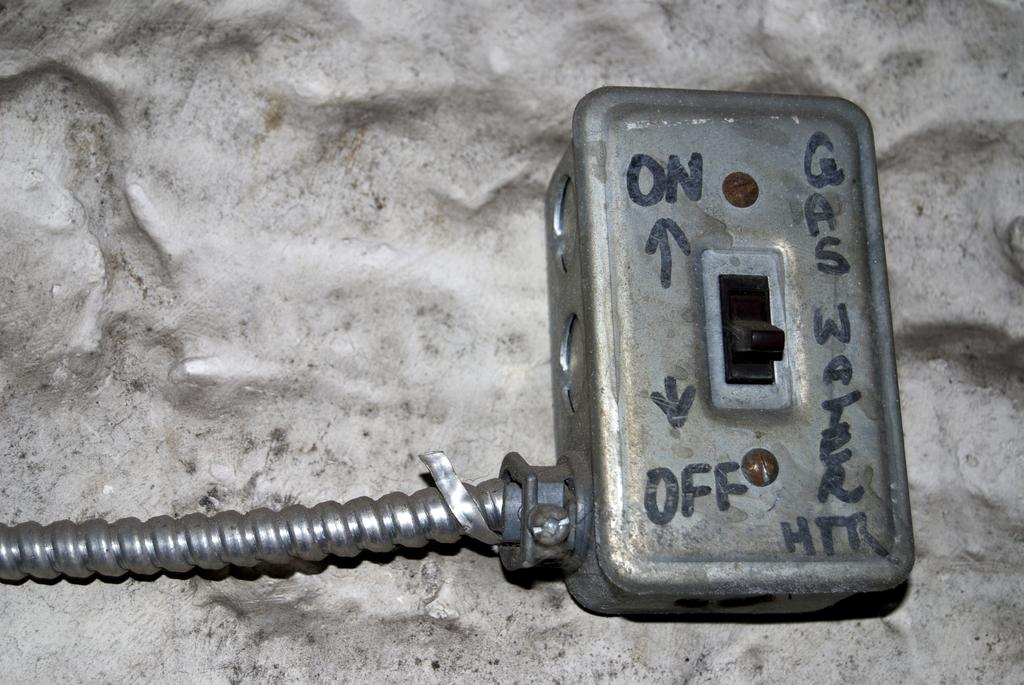<image>
Summarize the visual content of the image. An old switch has 'on', 'off', and 'Gas Water HTR' written on it in marker. 